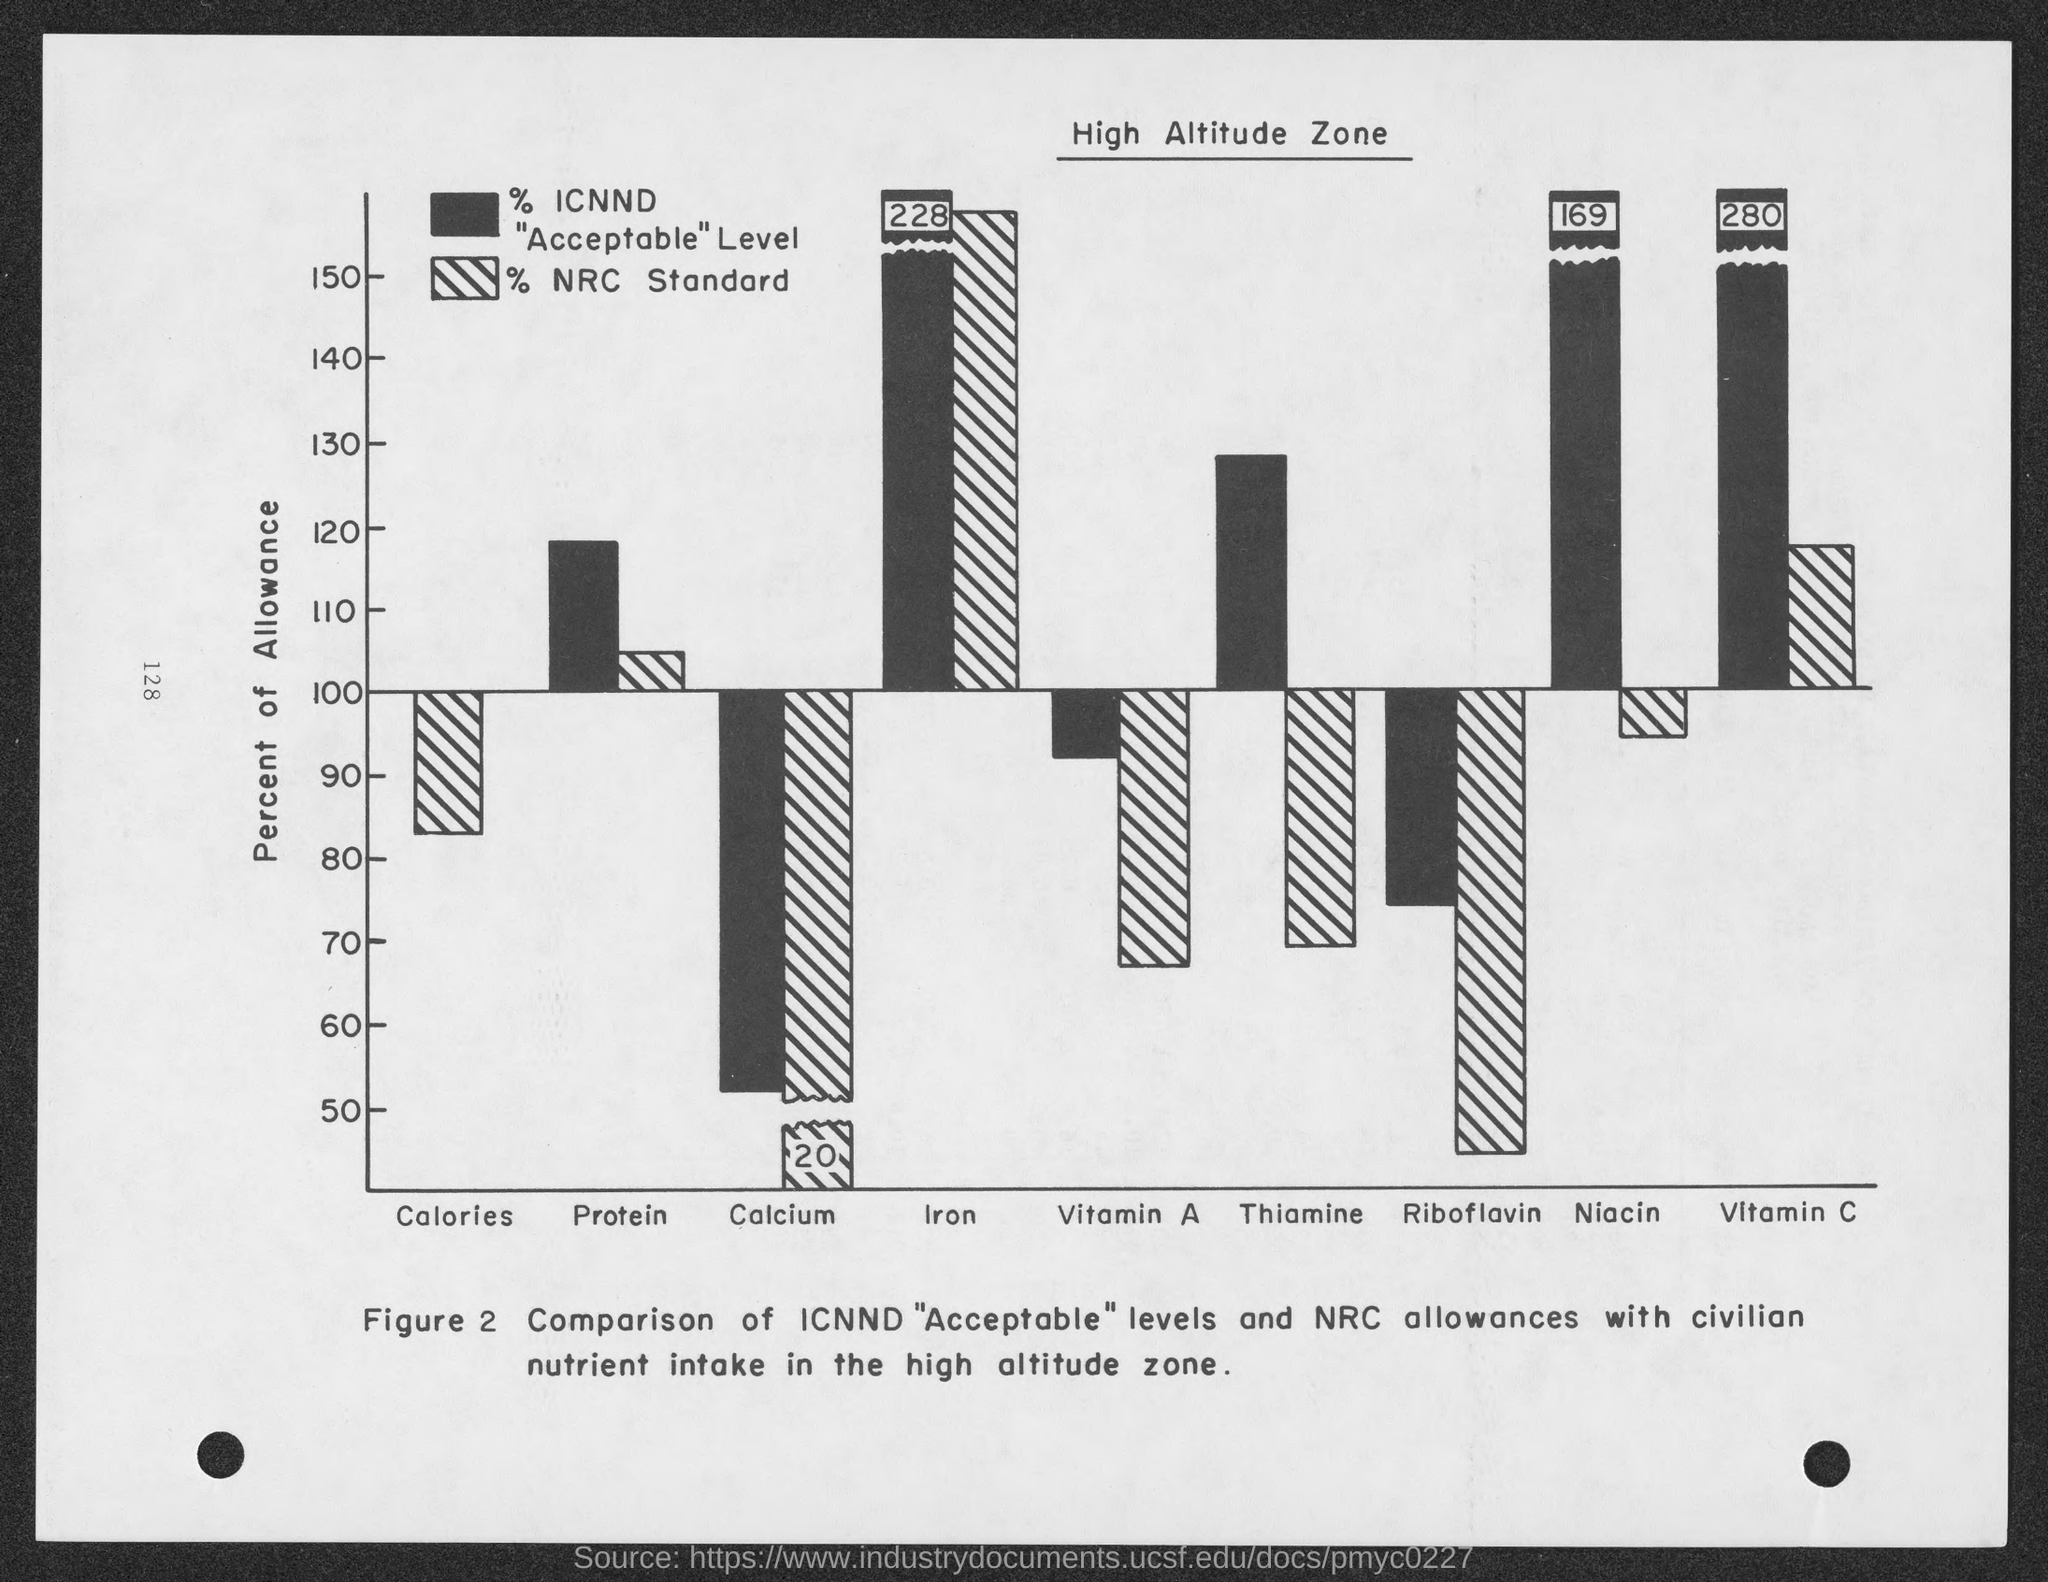List a handful of essential elements in this visual. The bar chart shows the percentage of allowance for each gender, with the Y axis representing the percentage of allowance. The figure caption compares "Acceptable" levels and NRC allowances for radiation exposure with civilian nutrient intake in the high altitude zone. 